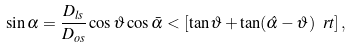<formula> <loc_0><loc_0><loc_500><loc_500>\sin { \alpha } = \frac { D _ { l s } } { D _ { o s } } \cos { \vartheta } \cos { \bar { \alpha } } < [ \tan { \vartheta } + \tan ( \hat { \alpha } - \vartheta ) \ r t ] \, ,</formula> 